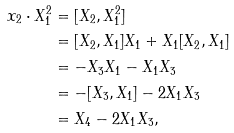Convert formula to latex. <formula><loc_0><loc_0><loc_500><loc_500>x _ { 2 } \cdot X _ { 1 } ^ { 2 } & = [ X _ { 2 } , X _ { 1 } ^ { 2 } ] \\ & = [ X _ { 2 } , X _ { 1 } ] X _ { 1 } + X _ { 1 } [ X _ { 2 } , X _ { 1 } ] \\ & = - X _ { 3 } X _ { 1 } - X _ { 1 } X _ { 3 } \\ & = - [ X _ { 3 } , X _ { 1 } ] - 2 X _ { 1 } X _ { 3 } \\ & = X _ { 4 } - 2 X _ { 1 } X _ { 3 } ,</formula> 